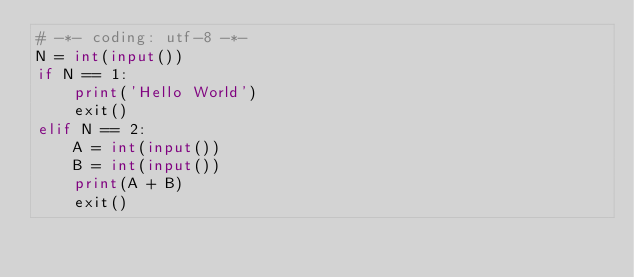Convert code to text. <code><loc_0><loc_0><loc_500><loc_500><_Python_># -*- coding: utf-8 -*-
N = int(input())
if N == 1:
    print('Hello World')
    exit()
elif N == 2:
    A = int(input())
    B = int(input())
    print(A + B)
    exit()</code> 